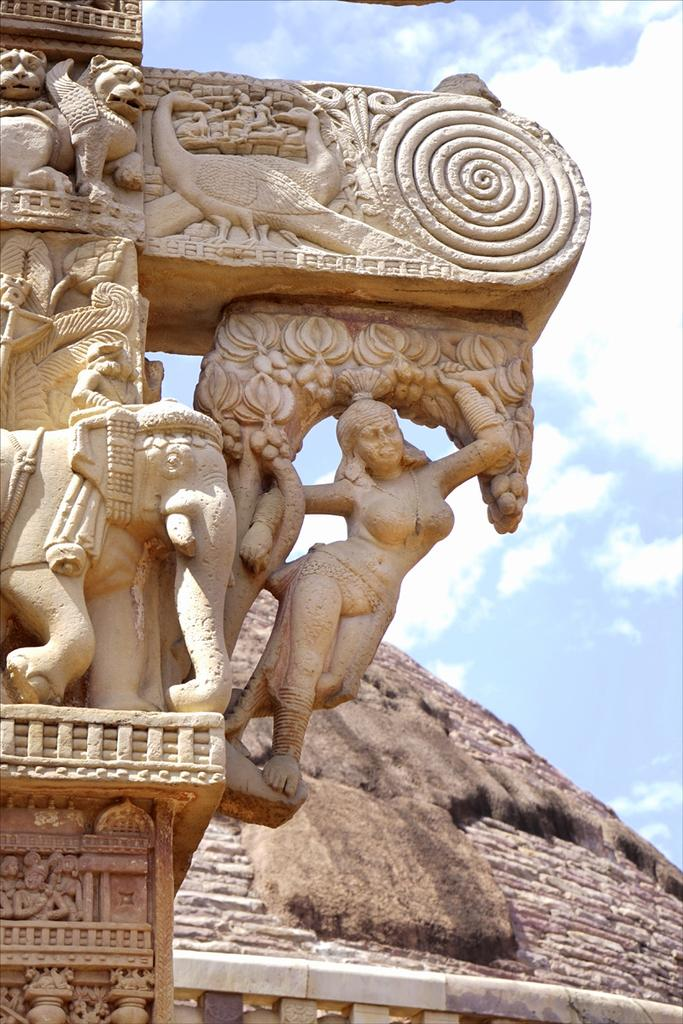What type of art is featured in the image? There are sculptures in the image. What can be seen in the background of the image? There is a rock hill and the sky visible in the background of the image. What is the condition of the sky in the image? Clouds are present in the sky. What word is written on the hall in the image? There is no hall or word present in the image; it features sculptures and a rock hill in the background. How many laborers can be seen working on the sculptures in the image? There are no laborers visible in the image; it only shows the sculptures and the background. 